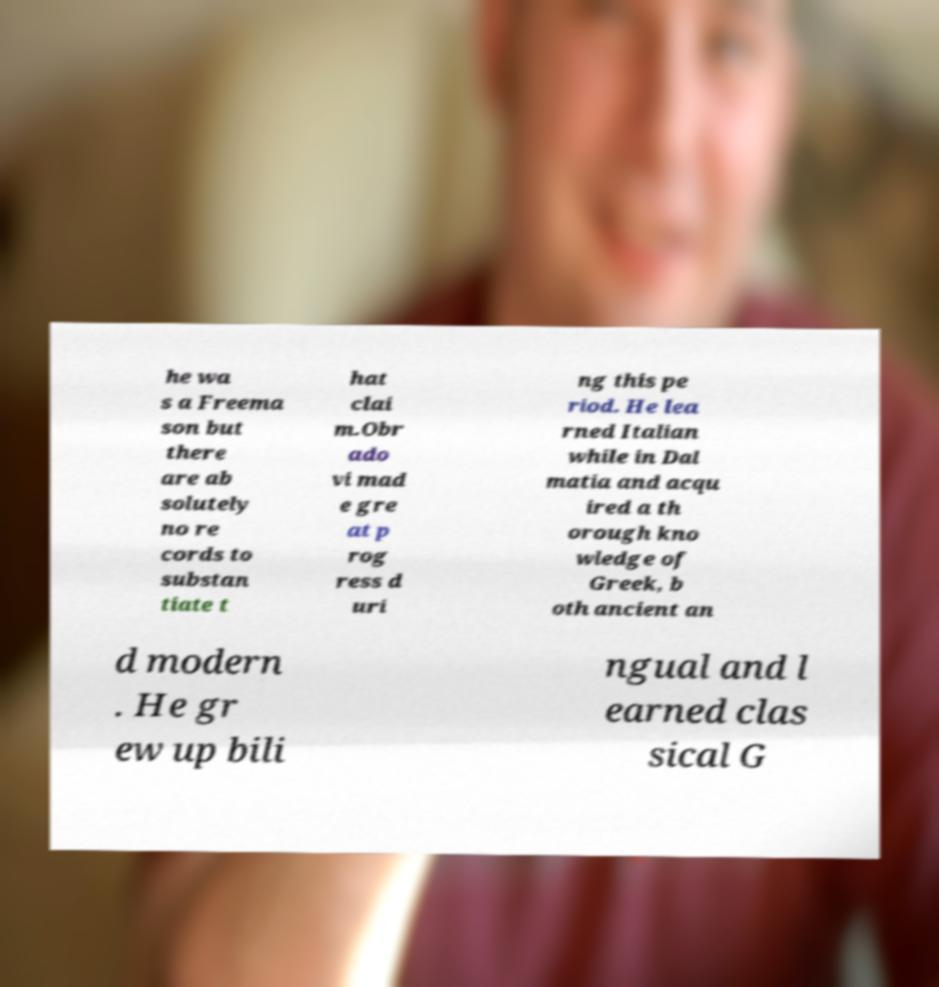Could you assist in decoding the text presented in this image and type it out clearly? he wa s a Freema son but there are ab solutely no re cords to substan tiate t hat clai m.Obr ado vi mad e gre at p rog ress d uri ng this pe riod. He lea rned Italian while in Dal matia and acqu ired a th orough kno wledge of Greek, b oth ancient an d modern . He gr ew up bili ngual and l earned clas sical G 